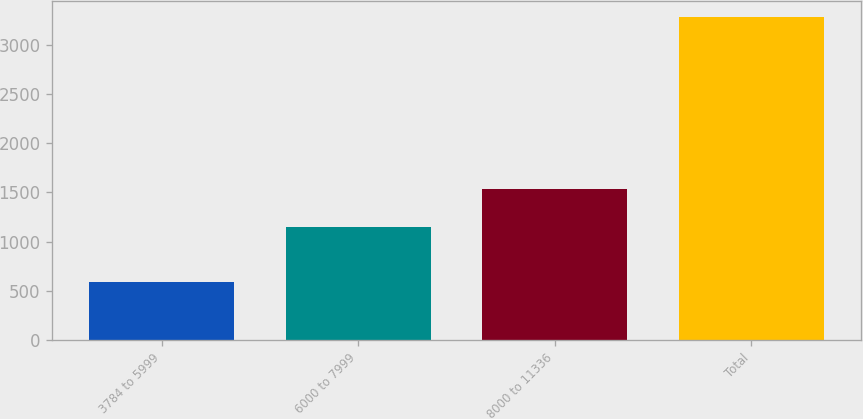<chart> <loc_0><loc_0><loc_500><loc_500><bar_chart><fcel>3784 to 5999<fcel>6000 to 7999<fcel>8000 to 11336<fcel>Total<nl><fcel>593<fcel>1151<fcel>1536<fcel>3280<nl></chart> 